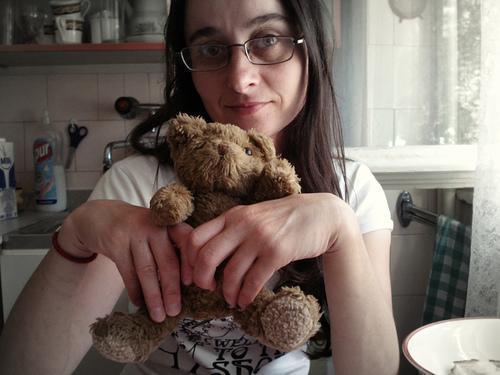How many skateboards are visible in the image?
Give a very brief answer. 0. 